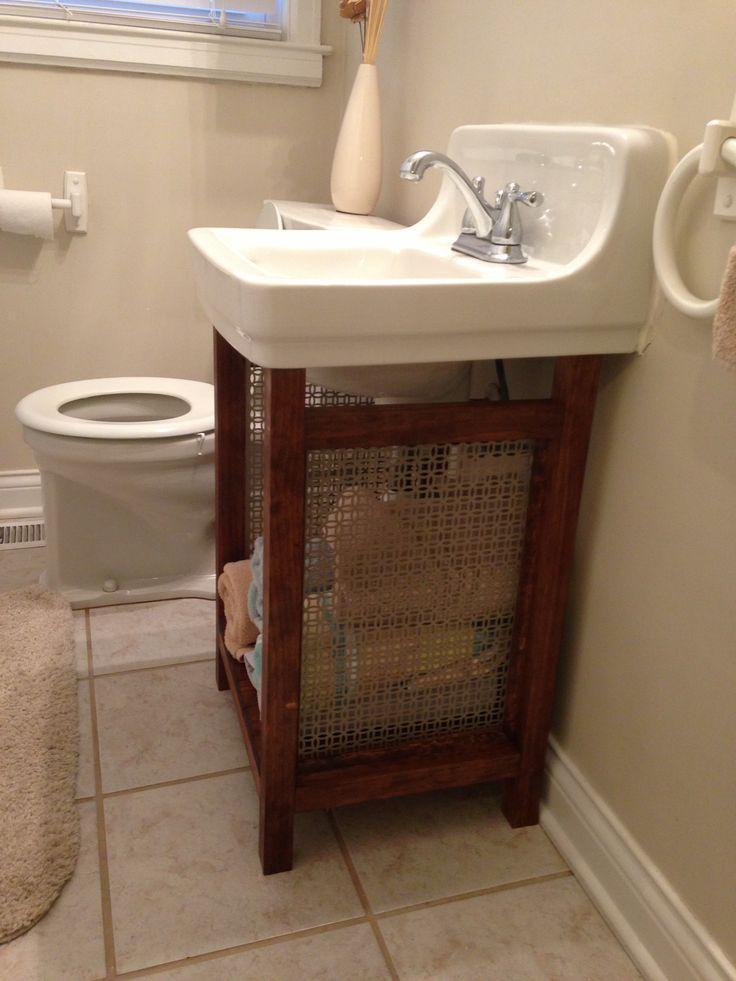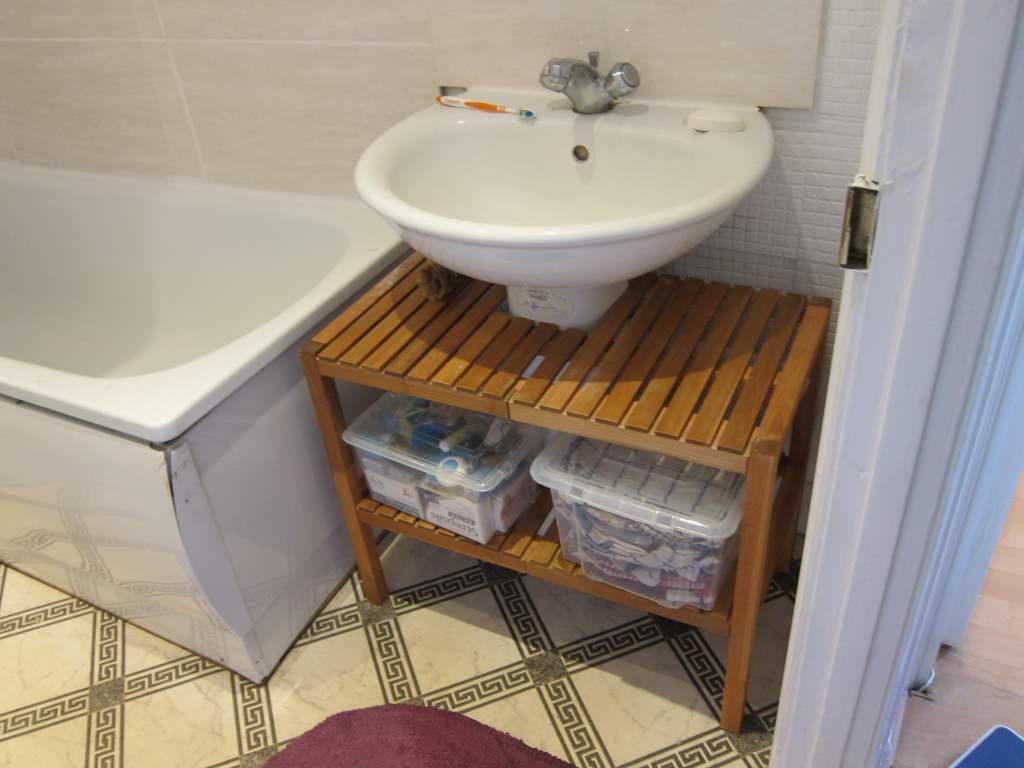The first image is the image on the left, the second image is the image on the right. Given the left and right images, does the statement "One of the images displays more than one sink." hold true? Answer yes or no. No. The first image is the image on the left, the second image is the image on the right. For the images shown, is this caption "A mirror is on a yellow wall above a white sink in one bathroom." true? Answer yes or no. No. 